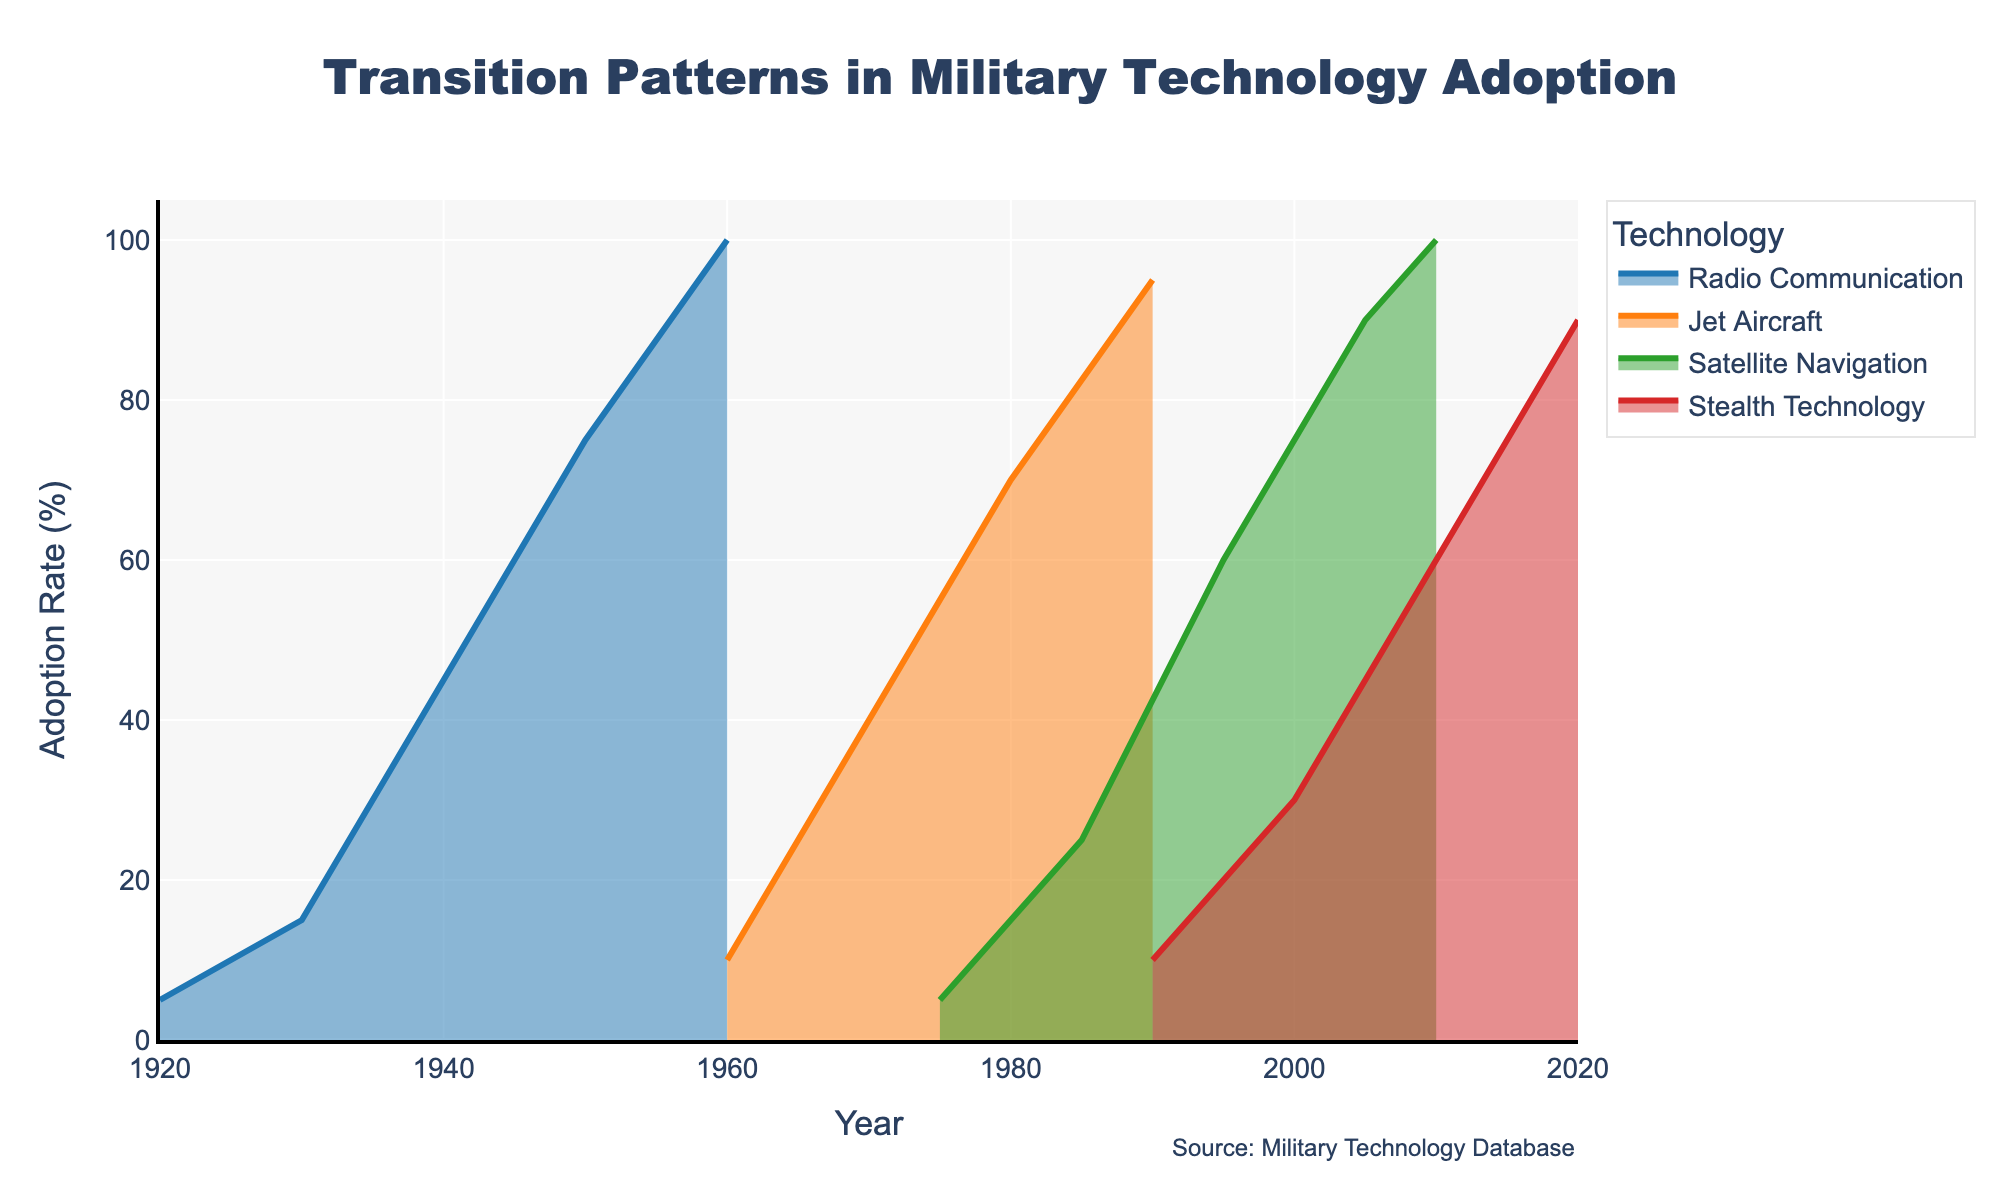What is the title of the figure? The title of the figure is generally located at the top of the chart in a large, prominent font. In this case, the title reads "Transition Patterns in Military Technology Adoption."
Answer: Transition Patterns in Military Technology Adoption Which technology reached 100% adoption rate first? By observing the adoption rate curves for different technologies, the technology that reaches 100% first is Radio Communication, which hits 100% in the year 1960.
Answer: Radio Communication What is the adoption rate of Jet Aircraft in 1970? To find this, look at the curve corresponding to Jet Aircraft in the year 1970. The rate at this point is about 40%.
Answer: 40% Add up the adoption rates for Satellite Navigation in 1975, 1985, and 1995. The adoption rates for Satellite Navigation are 5% in 1975, 25% in 1985, and 60% in 1995. Adding these together gives 5 + 25 + 60 = 90.
Answer: 90% Which technology shows the fastest growth in adoption rate during its initial phase? To determine the fastest growth, compare the slopes of the adoption rate curves for each technology in their initial phases. Stealth Technology grows from 10% in 1990 to 30% in 2000, a clear, consistent growth in a short span compared to others.
Answer: Stealth Technology When did Radio Communication first exceed 50% adoption rate? By examining the curve for Radio Communication, it surpasses 50% adoption rate sometime between 1940 and 1950. Looking closer, it appears exactly at 75% in 1950, so 50% would have been exceeded just before 1950.
Answer: Just before 1950 How does the adoption rate of Stealth Technology in 2000 compare to that of Satellite Navigation in 2000? Locate the curves for Stealth Technology and Satellite Navigation in the year 2000. The adoption rate for Stealth Technology is 30%, while Satellite Navigation is at 60%. Therefore, Stealth Technology's adoption rate is lower.
Answer: Stealth Technology is lower What is the average adoption rate of Stealth Technology over the years 1990, 2000, 2010, and 2020? The adoption rates for Stealth Technology are 10% in 1990, 30% in 2000, 60% in 2010, and 90% in 2020. The average is calculated as (10 + 30 + 60 + 90) / 4 = 47.5%.
Answer: 47.5% What year saw Satellite Navigation reaching the 90% adoption rate? By examining the adoption curve for Satellite Navigation, it reaches 90% in the year 2005.
Answer: 2005 